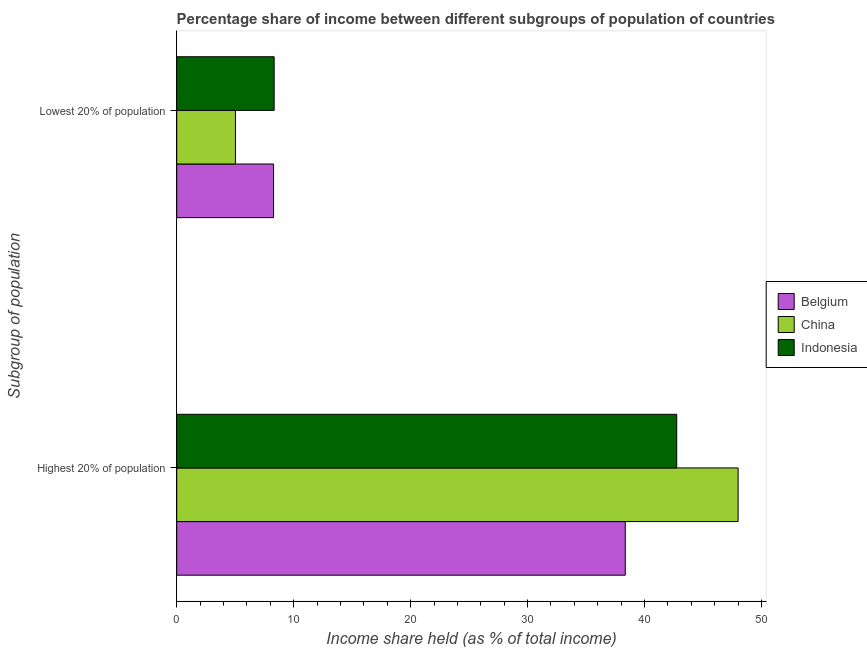How many different coloured bars are there?
Your answer should be compact. 3. How many groups of bars are there?
Ensure brevity in your answer.  2. How many bars are there on the 2nd tick from the top?
Offer a very short reply. 3. What is the label of the 2nd group of bars from the top?
Provide a short and direct response. Highest 20% of population. What is the income share held by highest 20% of the population in Belgium?
Your answer should be compact. 38.35. Across all countries, what is the maximum income share held by highest 20% of the population?
Make the answer very short. 48. Across all countries, what is the minimum income share held by lowest 20% of the population?
Offer a very short reply. 5.02. In which country was the income share held by lowest 20% of the population minimum?
Your answer should be compact. China. What is the total income share held by lowest 20% of the population in the graph?
Provide a short and direct response. 21.63. What is the difference between the income share held by highest 20% of the population in Belgium and that in Indonesia?
Ensure brevity in your answer.  -4.4. What is the difference between the income share held by lowest 20% of the population in Belgium and the income share held by highest 20% of the population in Indonesia?
Give a very brief answer. -34.47. What is the average income share held by lowest 20% of the population per country?
Ensure brevity in your answer.  7.21. What is the difference between the income share held by lowest 20% of the population and income share held by highest 20% of the population in China?
Provide a succinct answer. -42.98. What is the ratio of the income share held by highest 20% of the population in Indonesia to that in Belgium?
Offer a terse response. 1.11. Are all the bars in the graph horizontal?
Your answer should be very brief. Yes. How many countries are there in the graph?
Your answer should be very brief. 3. What is the difference between two consecutive major ticks on the X-axis?
Your answer should be compact. 10. Does the graph contain any zero values?
Offer a terse response. No. What is the title of the graph?
Make the answer very short. Percentage share of income between different subgroups of population of countries. What is the label or title of the X-axis?
Your answer should be compact. Income share held (as % of total income). What is the label or title of the Y-axis?
Ensure brevity in your answer.  Subgroup of population. What is the Income share held (as % of total income) of Belgium in Highest 20% of population?
Provide a short and direct response. 38.35. What is the Income share held (as % of total income) in China in Highest 20% of population?
Offer a terse response. 48. What is the Income share held (as % of total income) of Indonesia in Highest 20% of population?
Offer a very short reply. 42.75. What is the Income share held (as % of total income) of Belgium in Lowest 20% of population?
Give a very brief answer. 8.28. What is the Income share held (as % of total income) in China in Lowest 20% of population?
Provide a short and direct response. 5.02. What is the Income share held (as % of total income) of Indonesia in Lowest 20% of population?
Give a very brief answer. 8.33. Across all Subgroup of population, what is the maximum Income share held (as % of total income) of Belgium?
Your answer should be very brief. 38.35. Across all Subgroup of population, what is the maximum Income share held (as % of total income) of China?
Ensure brevity in your answer.  48. Across all Subgroup of population, what is the maximum Income share held (as % of total income) of Indonesia?
Your answer should be very brief. 42.75. Across all Subgroup of population, what is the minimum Income share held (as % of total income) in Belgium?
Provide a short and direct response. 8.28. Across all Subgroup of population, what is the minimum Income share held (as % of total income) in China?
Make the answer very short. 5.02. Across all Subgroup of population, what is the minimum Income share held (as % of total income) in Indonesia?
Keep it short and to the point. 8.33. What is the total Income share held (as % of total income) of Belgium in the graph?
Provide a short and direct response. 46.63. What is the total Income share held (as % of total income) in China in the graph?
Provide a succinct answer. 53.02. What is the total Income share held (as % of total income) of Indonesia in the graph?
Provide a short and direct response. 51.08. What is the difference between the Income share held (as % of total income) in Belgium in Highest 20% of population and that in Lowest 20% of population?
Provide a succinct answer. 30.07. What is the difference between the Income share held (as % of total income) in China in Highest 20% of population and that in Lowest 20% of population?
Your answer should be very brief. 42.98. What is the difference between the Income share held (as % of total income) of Indonesia in Highest 20% of population and that in Lowest 20% of population?
Keep it short and to the point. 34.42. What is the difference between the Income share held (as % of total income) in Belgium in Highest 20% of population and the Income share held (as % of total income) in China in Lowest 20% of population?
Provide a short and direct response. 33.33. What is the difference between the Income share held (as % of total income) of Belgium in Highest 20% of population and the Income share held (as % of total income) of Indonesia in Lowest 20% of population?
Your answer should be very brief. 30.02. What is the difference between the Income share held (as % of total income) of China in Highest 20% of population and the Income share held (as % of total income) of Indonesia in Lowest 20% of population?
Provide a succinct answer. 39.67. What is the average Income share held (as % of total income) in Belgium per Subgroup of population?
Make the answer very short. 23.32. What is the average Income share held (as % of total income) of China per Subgroup of population?
Offer a terse response. 26.51. What is the average Income share held (as % of total income) in Indonesia per Subgroup of population?
Your response must be concise. 25.54. What is the difference between the Income share held (as % of total income) in Belgium and Income share held (as % of total income) in China in Highest 20% of population?
Ensure brevity in your answer.  -9.65. What is the difference between the Income share held (as % of total income) of China and Income share held (as % of total income) of Indonesia in Highest 20% of population?
Provide a short and direct response. 5.25. What is the difference between the Income share held (as % of total income) of Belgium and Income share held (as % of total income) of China in Lowest 20% of population?
Keep it short and to the point. 3.26. What is the difference between the Income share held (as % of total income) in Belgium and Income share held (as % of total income) in Indonesia in Lowest 20% of population?
Your answer should be compact. -0.05. What is the difference between the Income share held (as % of total income) in China and Income share held (as % of total income) in Indonesia in Lowest 20% of population?
Your response must be concise. -3.31. What is the ratio of the Income share held (as % of total income) of Belgium in Highest 20% of population to that in Lowest 20% of population?
Keep it short and to the point. 4.63. What is the ratio of the Income share held (as % of total income) of China in Highest 20% of population to that in Lowest 20% of population?
Your answer should be very brief. 9.56. What is the ratio of the Income share held (as % of total income) in Indonesia in Highest 20% of population to that in Lowest 20% of population?
Keep it short and to the point. 5.13. What is the difference between the highest and the second highest Income share held (as % of total income) in Belgium?
Your answer should be compact. 30.07. What is the difference between the highest and the second highest Income share held (as % of total income) in China?
Ensure brevity in your answer.  42.98. What is the difference between the highest and the second highest Income share held (as % of total income) in Indonesia?
Your answer should be very brief. 34.42. What is the difference between the highest and the lowest Income share held (as % of total income) in Belgium?
Give a very brief answer. 30.07. What is the difference between the highest and the lowest Income share held (as % of total income) in China?
Keep it short and to the point. 42.98. What is the difference between the highest and the lowest Income share held (as % of total income) in Indonesia?
Provide a short and direct response. 34.42. 